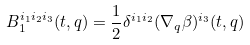<formula> <loc_0><loc_0><loc_500><loc_500>B _ { 1 } ^ { i _ { 1 } i _ { 2 } i _ { 3 } } ( t , q ) = \frac { 1 } { 2 } \delta ^ { i _ { 1 } i _ { 2 } } ( \nabla _ { q } \beta ) ^ { i _ { 3 } } ( t , q )</formula> 